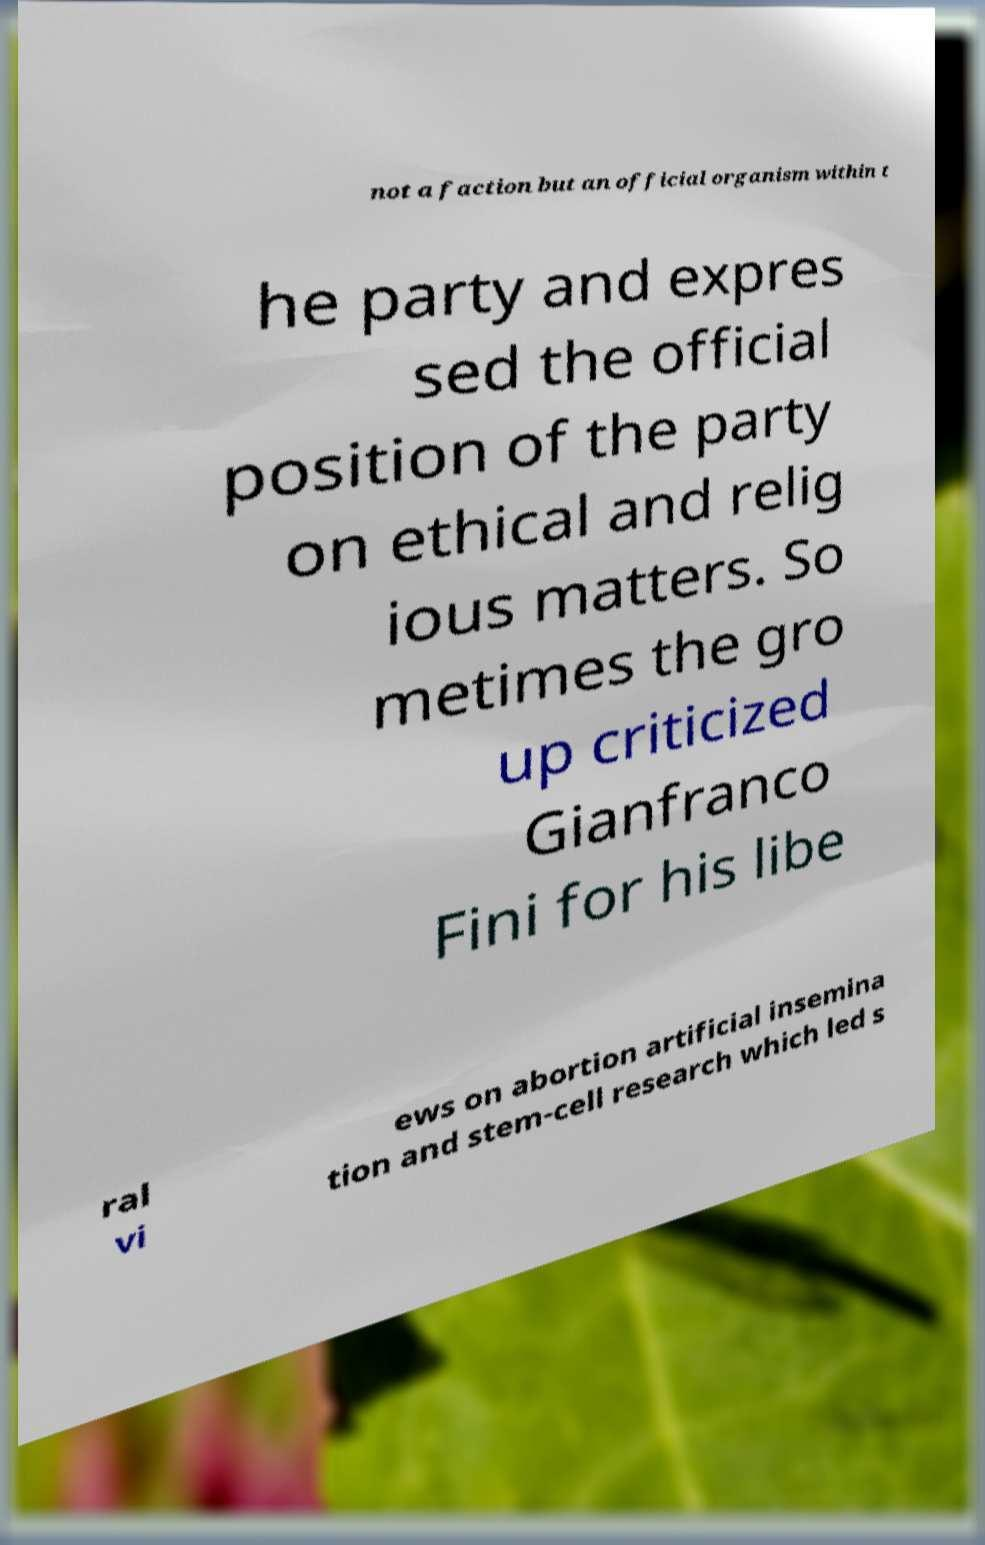There's text embedded in this image that I need extracted. Can you transcribe it verbatim? not a faction but an official organism within t he party and expres sed the official position of the party on ethical and relig ious matters. So metimes the gro up criticized Gianfranco Fini for his libe ral vi ews on abortion artificial insemina tion and stem-cell research which led s 